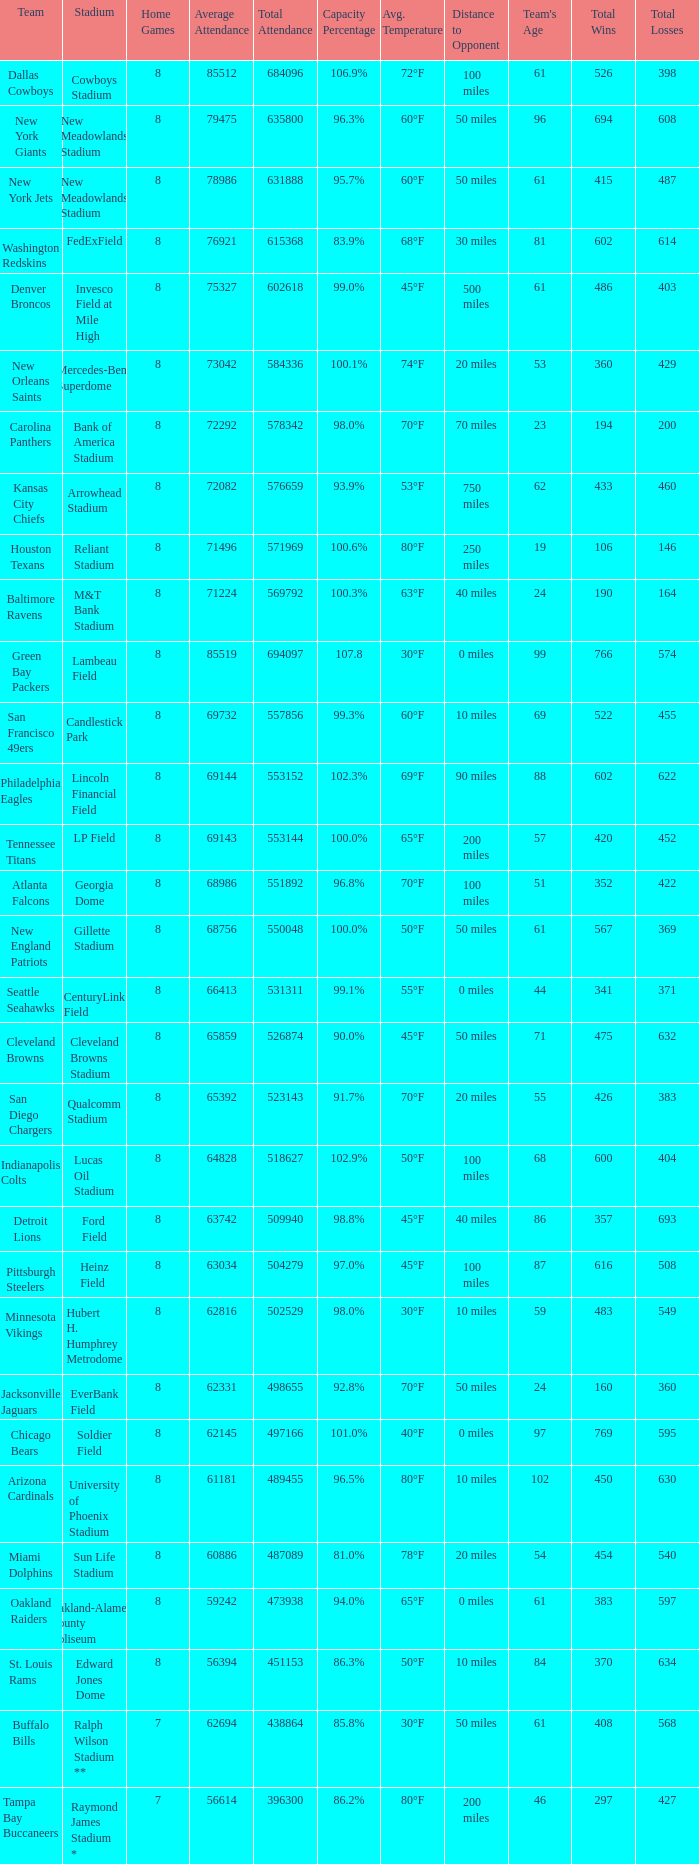How many home games are listed when the average attendance is 79475? 1.0. 